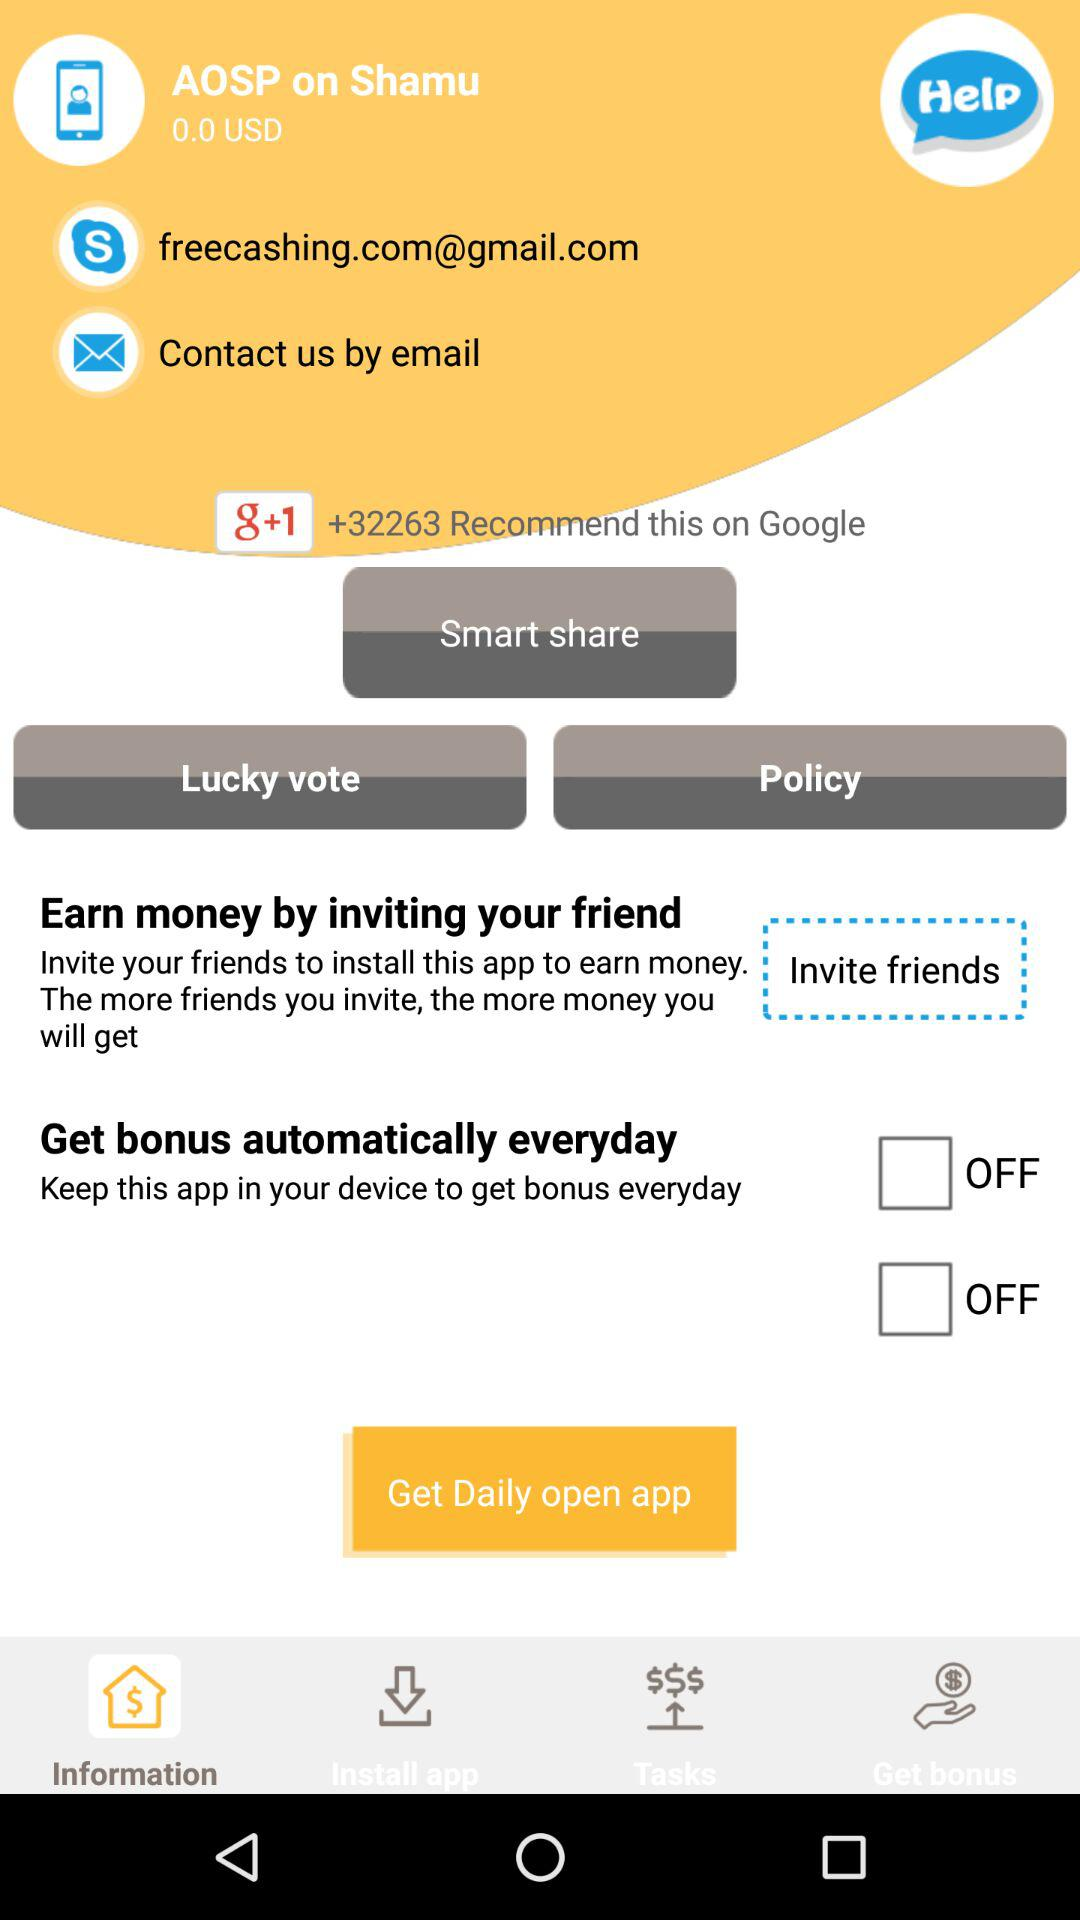What is the email address? The email address is freecashing.com@gmail.com. 